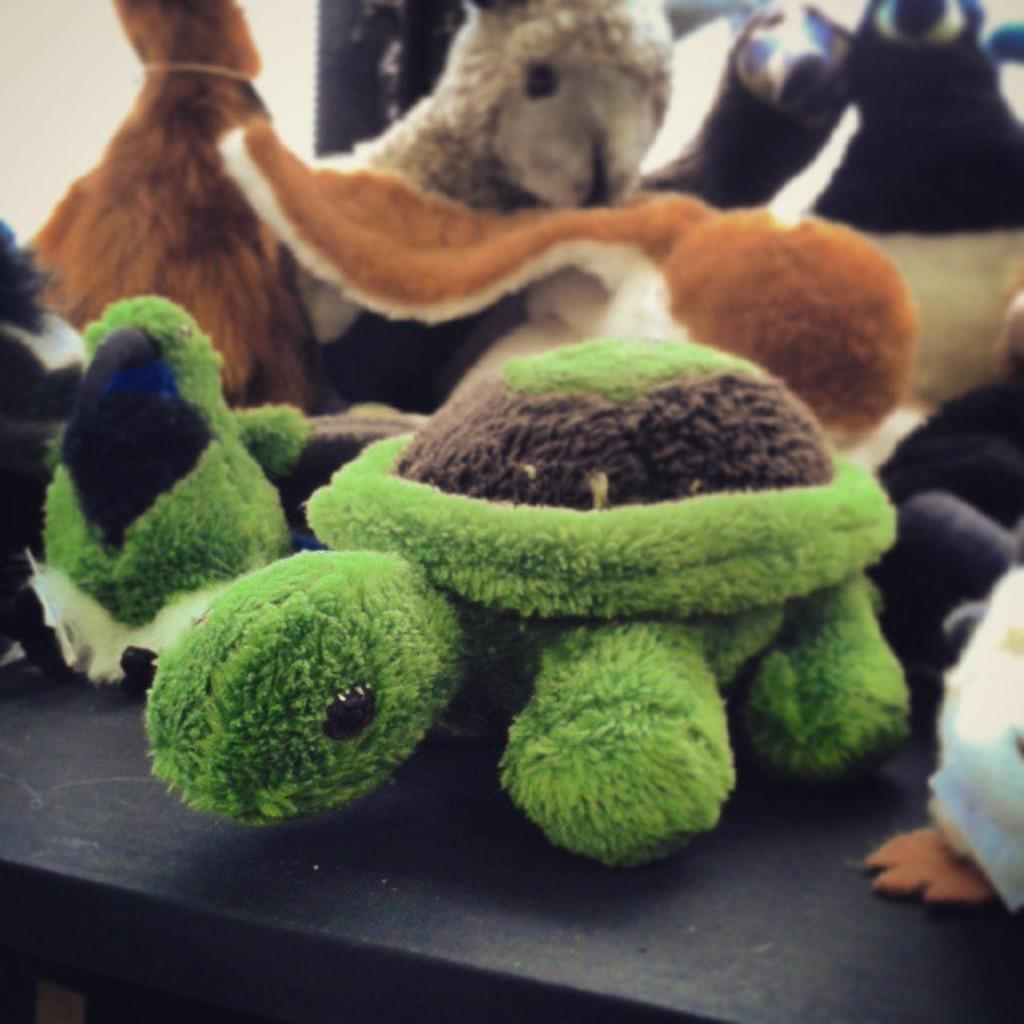What type of objects are present in the image? There are soft toys in the image. Can you describe the appearance of the soft toys? The soft toys are colorful. What is the color of the surface in the image? There is a black color surface in the image. Are there any fairies flying around the soft toys in the image? There are no fairies present in the image; it only features soft toys and a black surface. 